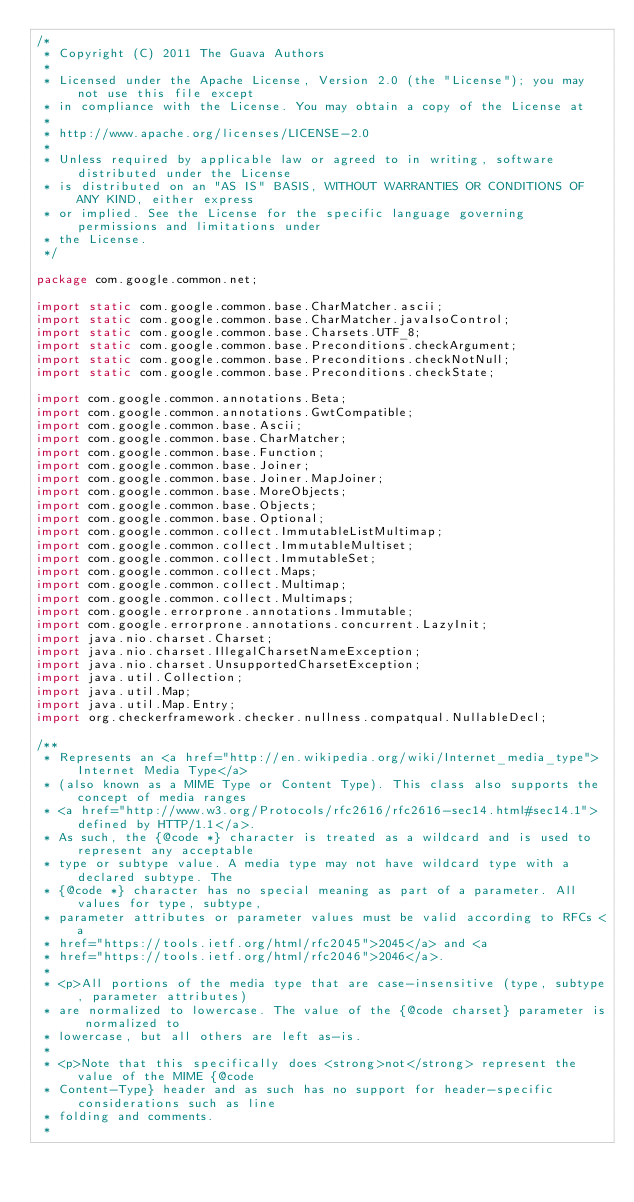<code> <loc_0><loc_0><loc_500><loc_500><_Java_>/*
 * Copyright (C) 2011 The Guava Authors
 *
 * Licensed under the Apache License, Version 2.0 (the "License"); you may not use this file except
 * in compliance with the License. You may obtain a copy of the License at
 *
 * http://www.apache.org/licenses/LICENSE-2.0
 *
 * Unless required by applicable law or agreed to in writing, software distributed under the License
 * is distributed on an "AS IS" BASIS, WITHOUT WARRANTIES OR CONDITIONS OF ANY KIND, either express
 * or implied. See the License for the specific language governing permissions and limitations under
 * the License.
 */

package com.google.common.net;

import static com.google.common.base.CharMatcher.ascii;
import static com.google.common.base.CharMatcher.javaIsoControl;
import static com.google.common.base.Charsets.UTF_8;
import static com.google.common.base.Preconditions.checkArgument;
import static com.google.common.base.Preconditions.checkNotNull;
import static com.google.common.base.Preconditions.checkState;

import com.google.common.annotations.Beta;
import com.google.common.annotations.GwtCompatible;
import com.google.common.base.Ascii;
import com.google.common.base.CharMatcher;
import com.google.common.base.Function;
import com.google.common.base.Joiner;
import com.google.common.base.Joiner.MapJoiner;
import com.google.common.base.MoreObjects;
import com.google.common.base.Objects;
import com.google.common.base.Optional;
import com.google.common.collect.ImmutableListMultimap;
import com.google.common.collect.ImmutableMultiset;
import com.google.common.collect.ImmutableSet;
import com.google.common.collect.Maps;
import com.google.common.collect.Multimap;
import com.google.common.collect.Multimaps;
import com.google.errorprone.annotations.Immutable;
import com.google.errorprone.annotations.concurrent.LazyInit;
import java.nio.charset.Charset;
import java.nio.charset.IllegalCharsetNameException;
import java.nio.charset.UnsupportedCharsetException;
import java.util.Collection;
import java.util.Map;
import java.util.Map.Entry;
import org.checkerframework.checker.nullness.compatqual.NullableDecl;

/**
 * Represents an <a href="http://en.wikipedia.org/wiki/Internet_media_type">Internet Media Type</a>
 * (also known as a MIME Type or Content Type). This class also supports the concept of media ranges
 * <a href="http://www.w3.org/Protocols/rfc2616/rfc2616-sec14.html#sec14.1">defined by HTTP/1.1</a>.
 * As such, the {@code *} character is treated as a wildcard and is used to represent any acceptable
 * type or subtype value. A media type may not have wildcard type with a declared subtype. The
 * {@code *} character has no special meaning as part of a parameter. All values for type, subtype,
 * parameter attributes or parameter values must be valid according to RFCs <a
 * href="https://tools.ietf.org/html/rfc2045">2045</a> and <a
 * href="https://tools.ietf.org/html/rfc2046">2046</a>.
 *
 * <p>All portions of the media type that are case-insensitive (type, subtype, parameter attributes)
 * are normalized to lowercase. The value of the {@code charset} parameter is normalized to
 * lowercase, but all others are left as-is.
 *
 * <p>Note that this specifically does <strong>not</strong> represent the value of the MIME {@code
 * Content-Type} header and as such has no support for header-specific considerations such as line
 * folding and comments.
 *</code> 